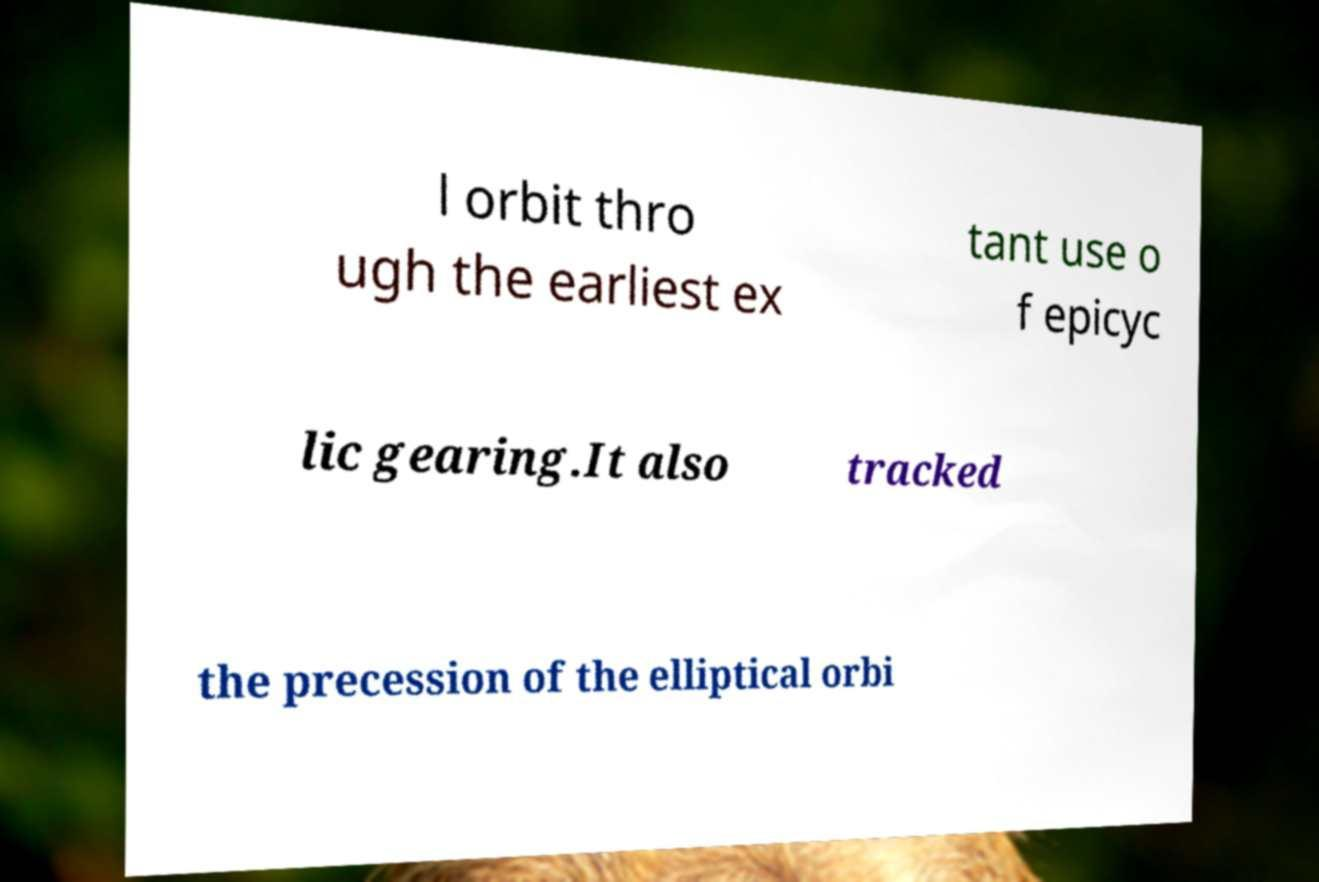What messages or text are displayed in this image? I need them in a readable, typed format. l orbit thro ugh the earliest ex tant use o f epicyc lic gearing.It also tracked the precession of the elliptical orbi 